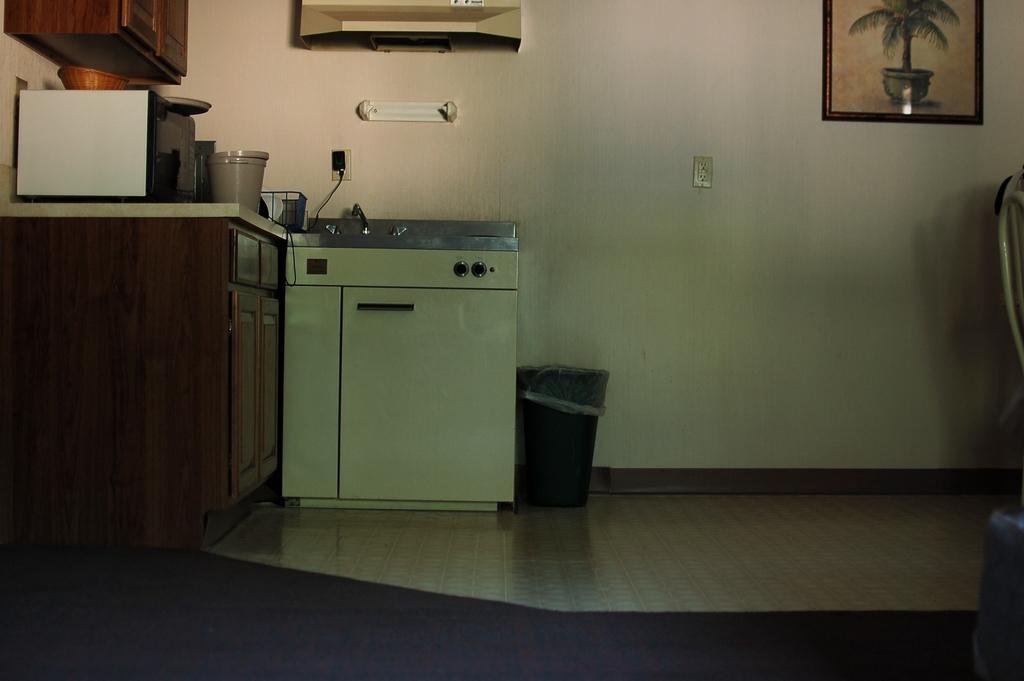In one or two sentences, can you explain what this image depicts? In this picture we can observe a stove. There is a trash bin beside the stove. There is an oven on the desk. We can observe cupboards which are in brown color. On the right side we can observe a photo frame fixed to the wall. 